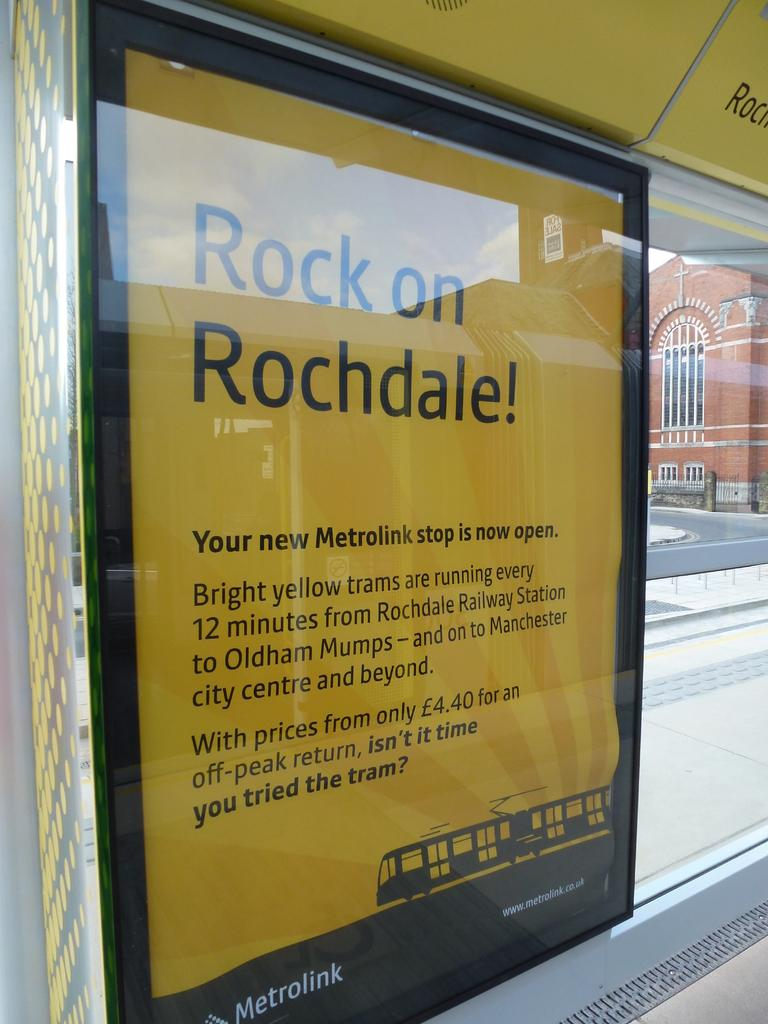Provide a one-sentence caption for the provided image. A bus stop advertisement informing riders about a new Metrolink stop. 